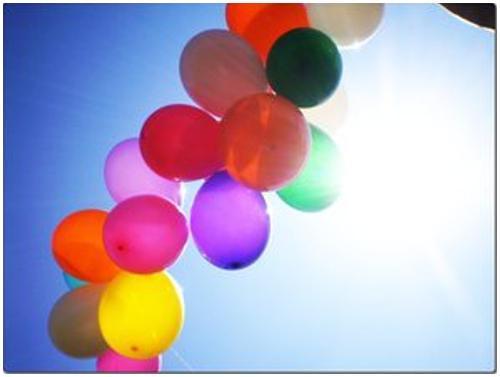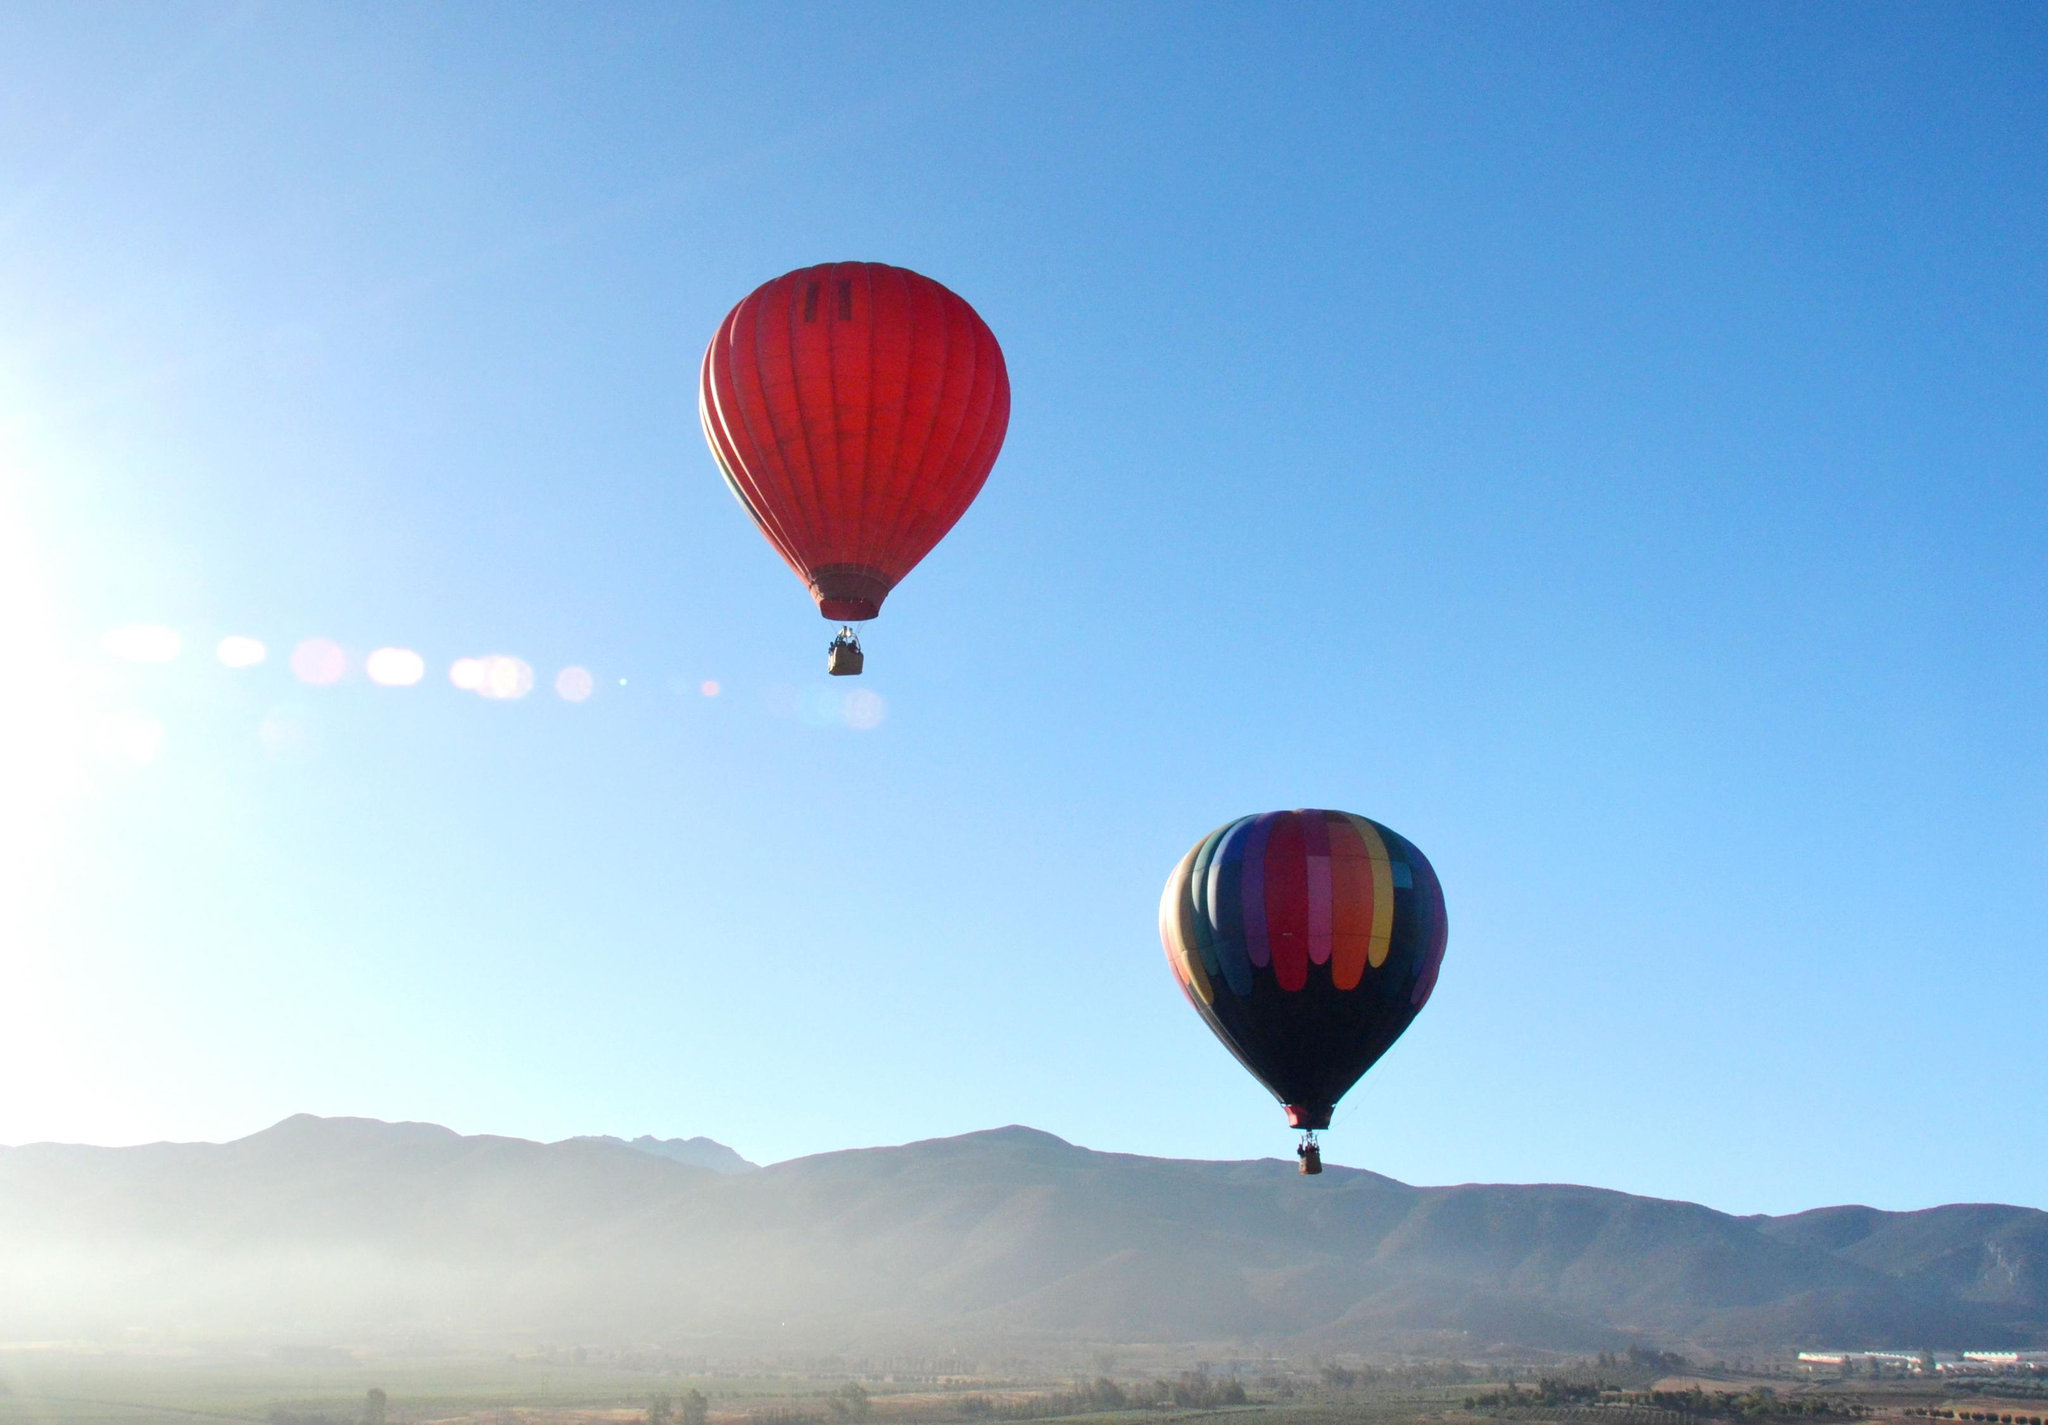The first image is the image on the left, the second image is the image on the right. Examine the images to the left and right. Is the description "The right image has no more than 2 balloons." accurate? Answer yes or no. Yes. The first image is the image on the left, the second image is the image on the right. Given the left and right images, does the statement "There are no more than two balloons in the sky in the image on the right." hold true? Answer yes or no. Yes. 